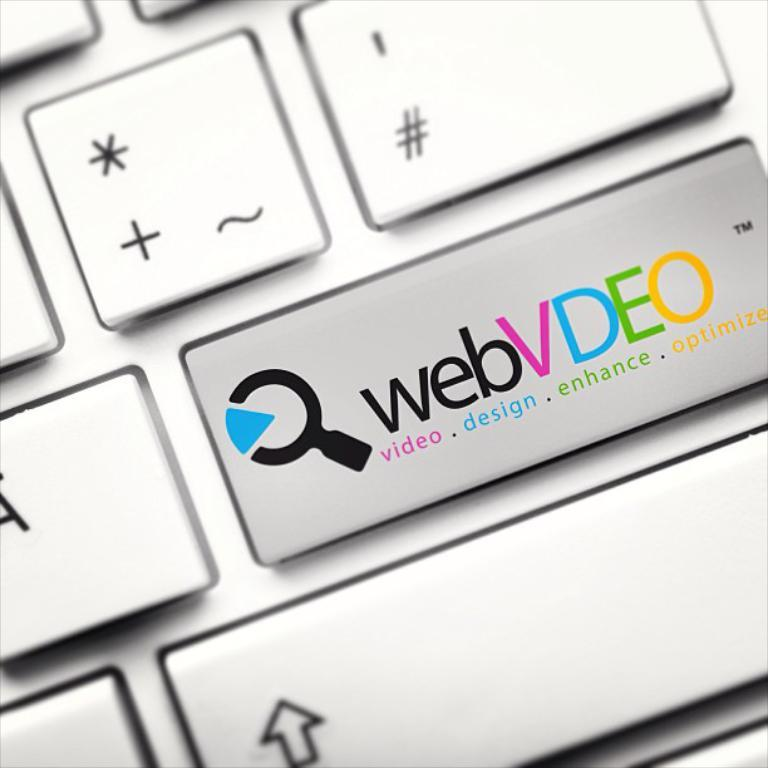What objects are present in the image? There are keys in the image. What features do the keys have? The keys have letters, symbols, an arrow mark, and a trademark symbol. How many snails can be seen crawling on the keys in the image? There are no snails present in the image; it only features keys with letters, symbols, an arrow mark, and a trademark symbol. 